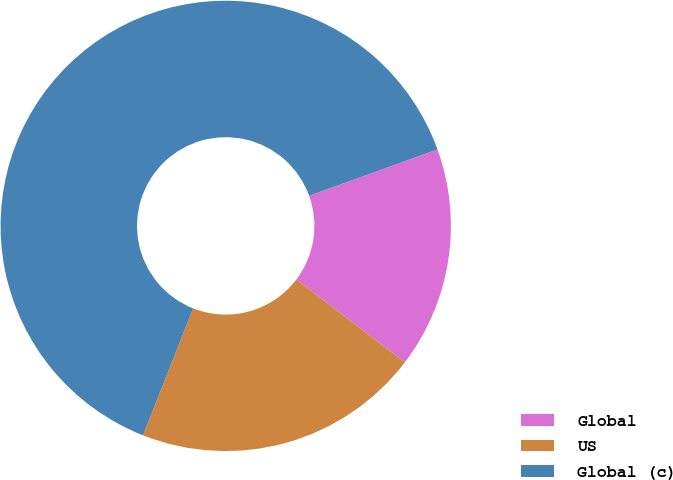Convert chart. <chart><loc_0><loc_0><loc_500><loc_500><pie_chart><fcel>Global<fcel>US<fcel>Global (c)<nl><fcel>15.87%<fcel>20.63%<fcel>63.49%<nl></chart> 